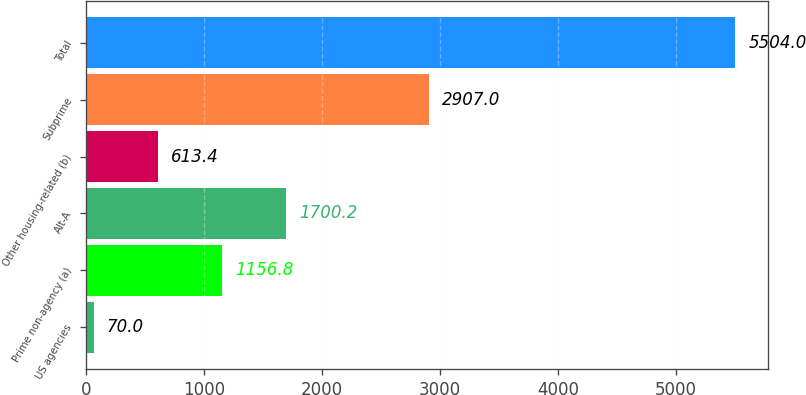<chart> <loc_0><loc_0><loc_500><loc_500><bar_chart><fcel>US agencies<fcel>Prime non-agency (a)<fcel>Alt-A<fcel>Other housing-related (b)<fcel>Subprime<fcel>Total<nl><fcel>70<fcel>1156.8<fcel>1700.2<fcel>613.4<fcel>2907<fcel>5504<nl></chart> 